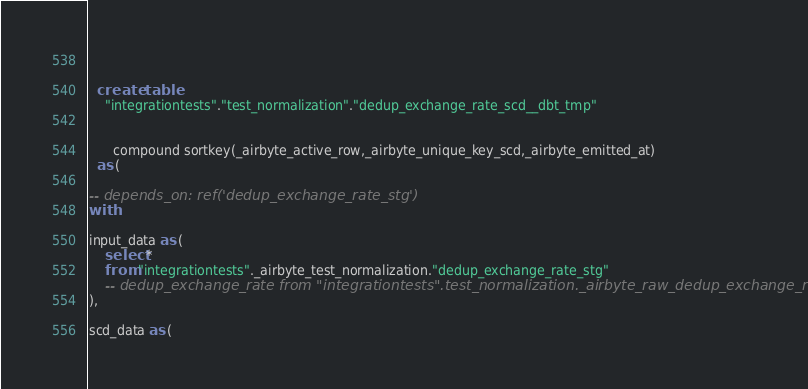<code> <loc_0><loc_0><loc_500><loc_500><_SQL_>
      

  create  table
    "integrationtests"."test_normalization"."dedup_exchange_rate_scd__dbt_tmp"
    
    
      compound sortkey(_airbyte_active_row,_airbyte_unique_key_scd,_airbyte_emitted_at)
  as (
    
-- depends_on: ref('dedup_exchange_rate_stg')
with

input_data as (
    select *
    from "integrationtests"._airbyte_test_normalization."dedup_exchange_rate_stg"
    -- dedup_exchange_rate from "integrationtests".test_normalization._airbyte_raw_dedup_exchange_rate
),

scd_data as (</code> 